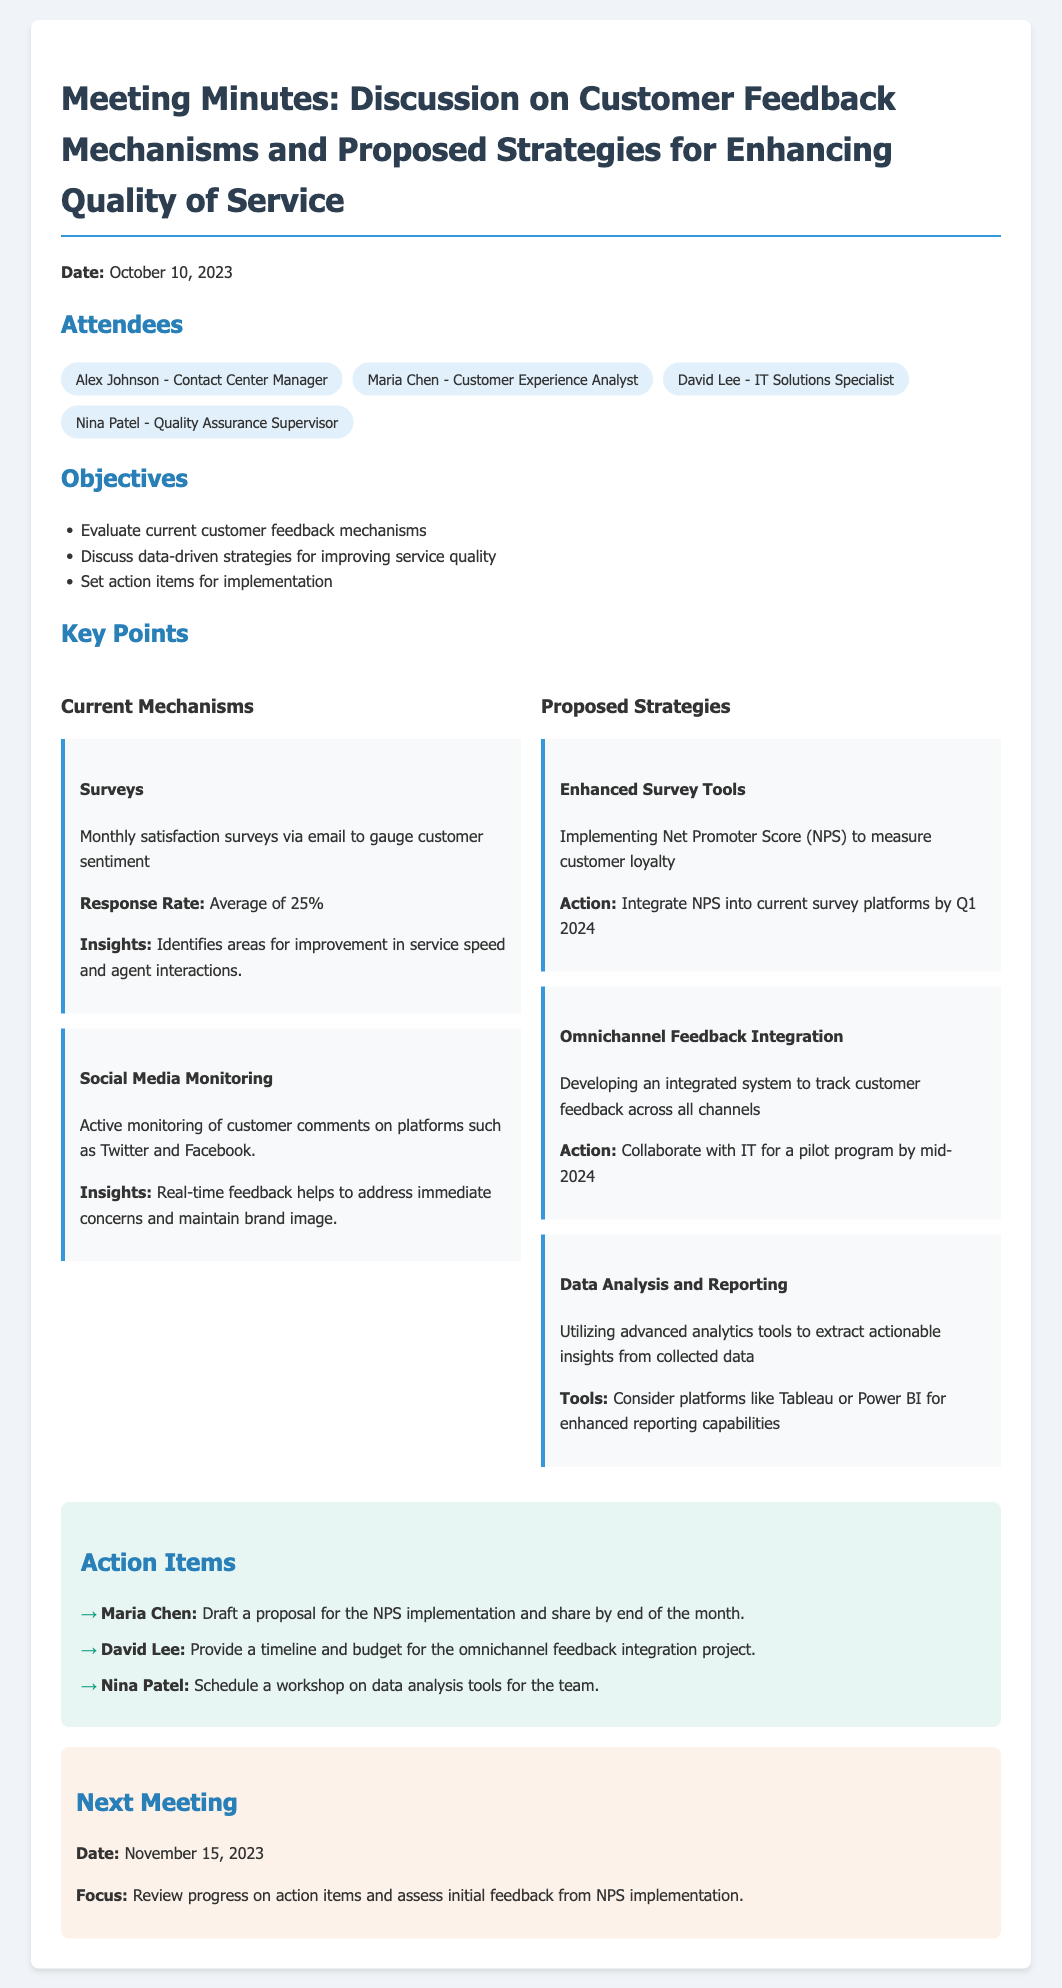What is the date of the meeting? The date of the meeting is specified at the top of the document.
Answer: October 10, 2023 Who is the Contact Center Manager? The title and name of the Contact Center Manager are listed under attendees.
Answer: Alex Johnson What is the average response rate for the surveys? The response rate is mentioned in the section about Current Mechanisms.
Answer: Average of 25% What is one proposed strategy for enhancing quality of service? Multiple strategies are outlined, and one can be found in the Proposed Strategies section.
Answer: Enhanced Survey Tools When is the next meeting scheduled? The next meeting date is provided in the last section of the document.
Answer: November 15, 2023 What tool is suggested for enhanced reporting capabilities? Tools for reporting are mentioned under the Data Analysis and Reporting section.
Answer: Tableau or Power BI Which attendee is responsible for drafting the NPS implementation proposal? The action items list specifies the individual for this task.
Answer: Maria Chen What is the objective related to data-driven strategies? The objective in the document outlines the purpose of discussing data-driven strategies.
Answer: Discuss data-driven strategies for improving service quality 